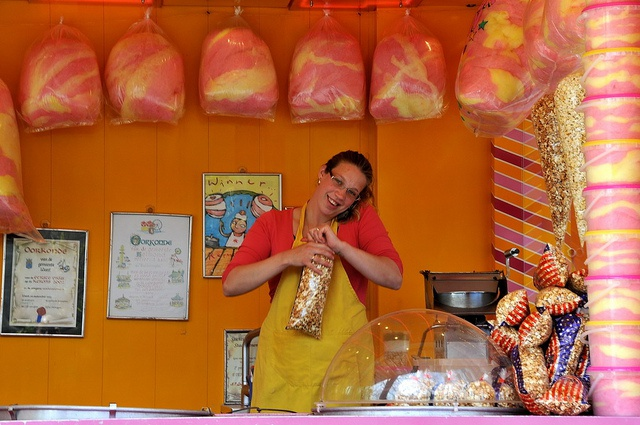Describe the objects in this image and their specific colors. I can see people in brown and olive tones and cell phone in black, maroon, and brown tones in this image. 